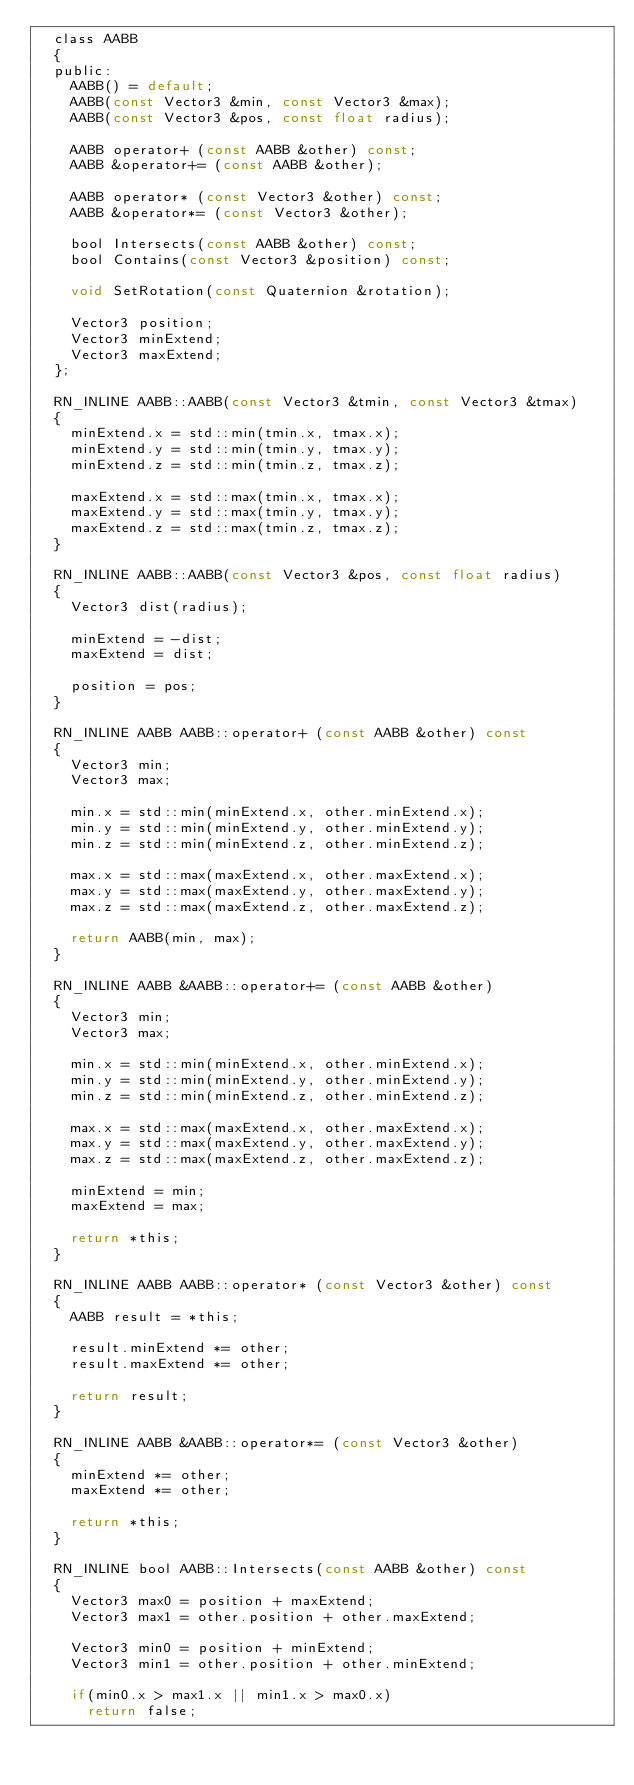Convert code to text. <code><loc_0><loc_0><loc_500><loc_500><_C_>	class AABB
	{
	public:
		AABB() = default;
		AABB(const Vector3 &min, const Vector3 &max);
		AABB(const Vector3 &pos, const float radius);

		AABB operator+ (const AABB &other) const;
		AABB &operator+= (const AABB &other);

		AABB operator* (const Vector3 &other) const;
		AABB &operator*= (const Vector3 &other);

		bool Intersects(const AABB &other) const;
		bool Contains(const Vector3 &position) const;

		void SetRotation(const Quaternion &rotation);

		Vector3 position;
		Vector3 minExtend;
		Vector3 maxExtend;
	};

	RN_INLINE AABB::AABB(const Vector3 &tmin, const Vector3 &tmax)
	{
		minExtend.x = std::min(tmin.x, tmax.x);
		minExtend.y = std::min(tmin.y, tmax.y);
		minExtend.z = std::min(tmin.z, tmax.z);

		maxExtend.x = std::max(tmin.x, tmax.x);
		maxExtend.y = std::max(tmin.y, tmax.y);
		maxExtend.z = std::max(tmin.z, tmax.z);
	}

	RN_INLINE AABB::AABB(const Vector3 &pos, const float radius)
	{
		Vector3 dist(radius);

		minExtend = -dist;
		maxExtend = dist;

		position = pos;
	}

	RN_INLINE AABB AABB::operator+ (const AABB &other) const
	{
		Vector3 min;
		Vector3 max;

		min.x = std::min(minExtend.x, other.minExtend.x);
		min.y = std::min(minExtend.y, other.minExtend.y);
		min.z = std::min(minExtend.z, other.minExtend.z);

		max.x = std::max(maxExtend.x, other.maxExtend.x);
		max.y = std::max(maxExtend.y, other.maxExtend.y);
		max.z = std::max(maxExtend.z, other.maxExtend.z);

		return AABB(min, max);
	}

	RN_INLINE AABB &AABB::operator+= (const AABB &other)
	{
		Vector3 min;
		Vector3 max;

		min.x = std::min(minExtend.x, other.minExtend.x);
		min.y = std::min(minExtend.y, other.minExtend.y);
		min.z = std::min(minExtend.z, other.minExtend.z);

		max.x = std::max(maxExtend.x, other.maxExtend.x);
		max.y = std::max(maxExtend.y, other.maxExtend.y);
		max.z = std::max(maxExtend.z, other.maxExtend.z);

		minExtend = min;
		maxExtend = max;

		return *this;
	}

	RN_INLINE AABB AABB::operator* (const Vector3 &other) const
	{
		AABB result = *this;

		result.minExtend *= other;
		result.maxExtend *= other;

		return result;
	}

	RN_INLINE AABB &AABB::operator*= (const Vector3 &other)
	{
		minExtend *= other;
		maxExtend *= other;

		return *this;
	}

	RN_INLINE bool AABB::Intersects(const AABB &other) const
	{
		Vector3 max0 = position + maxExtend;
		Vector3 max1 = other.position + other.maxExtend;

		Vector3 min0 = position + minExtend;
		Vector3 min1 = other.position + other.minExtend;

		if(min0.x > max1.x || min1.x > max0.x)
			return false;</code> 